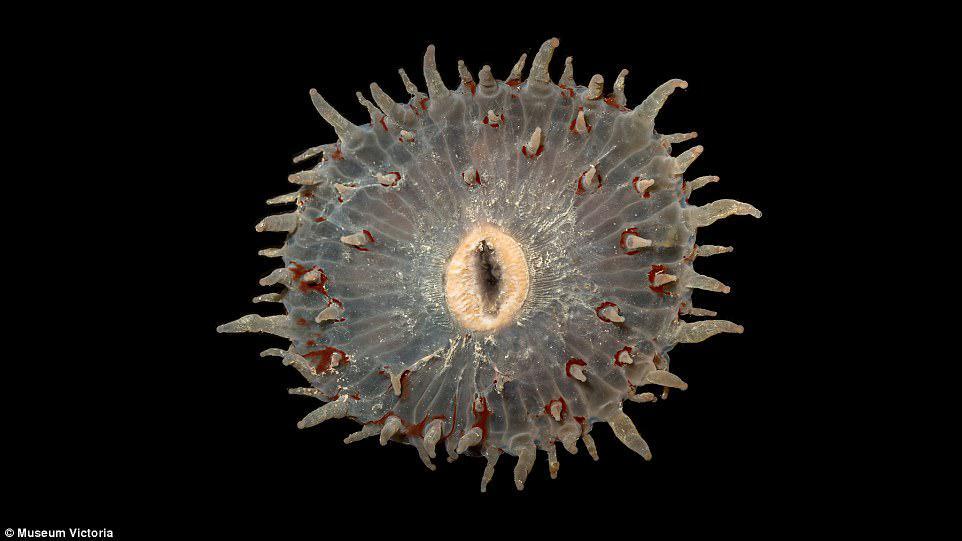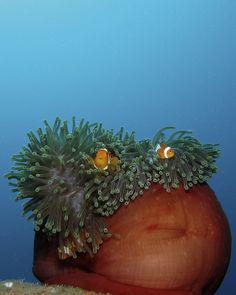The first image is the image on the left, the second image is the image on the right. Given the left and right images, does the statement "At least one of the organisms is a spherical shape." hold true? Answer yes or no. Yes. The first image is the image on the left, the second image is the image on the right. Considering the images on both sides, is "Each image contains one prominent roundish marine creature, and the image on the left shows an anemone with tapered orangish tendrils radiating from a center." valid? Answer yes or no. No. 